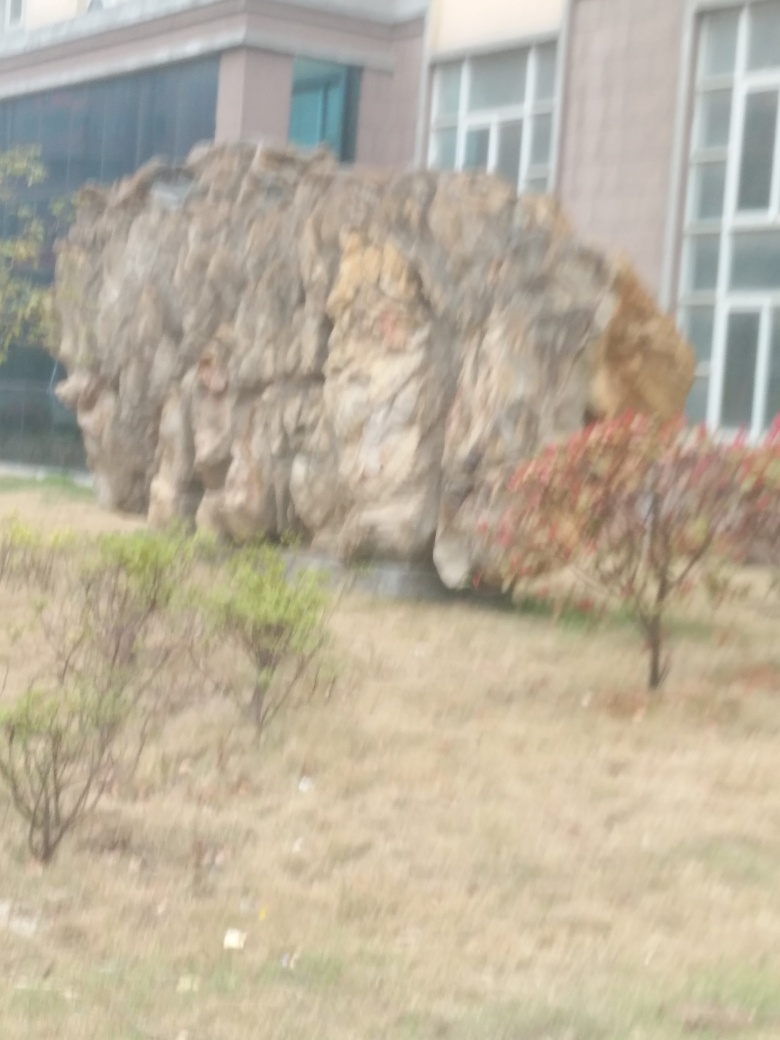What can be said about the clarity of the captured architecture? The image portrays a large rock or boulder with some vegetation in the foreground and a building partly visible in the background. Unfortunately, the clarity of the image is compromised by noticeable blurriness, making it difficult to make out fine details of the textures and structures present. 